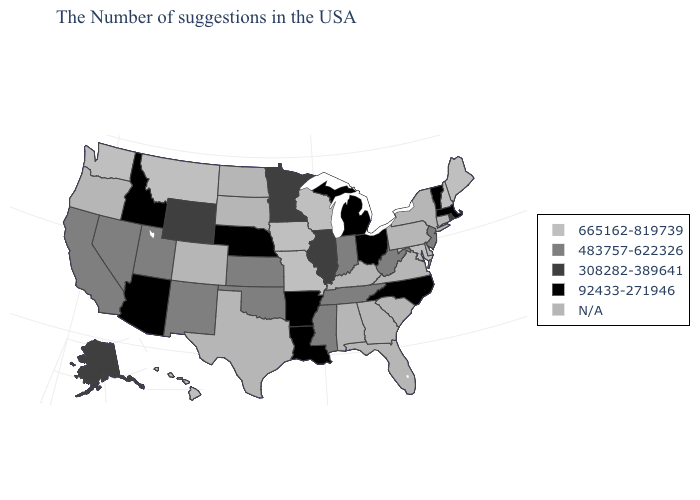Name the states that have a value in the range N/A?
Write a very short answer. Connecticut, New York, Delaware, Pennsylvania, Virginia, South Carolina, Florida, Georgia, Kentucky, Alabama, Texas, South Dakota, North Dakota, Colorado, Oregon. How many symbols are there in the legend?
Answer briefly. 5. Name the states that have a value in the range N/A?
Give a very brief answer. Connecticut, New York, Delaware, Pennsylvania, Virginia, South Carolina, Florida, Georgia, Kentucky, Alabama, Texas, South Dakota, North Dakota, Colorado, Oregon. Name the states that have a value in the range N/A?
Concise answer only. Connecticut, New York, Delaware, Pennsylvania, Virginia, South Carolina, Florida, Georgia, Kentucky, Alabama, Texas, South Dakota, North Dakota, Colorado, Oregon. What is the lowest value in the Northeast?
Be succinct. 92433-271946. Name the states that have a value in the range N/A?
Concise answer only. Connecticut, New York, Delaware, Pennsylvania, Virginia, South Carolina, Florida, Georgia, Kentucky, Alabama, Texas, South Dakota, North Dakota, Colorado, Oregon. Does the first symbol in the legend represent the smallest category?
Write a very short answer. No. Does Ohio have the highest value in the USA?
Write a very short answer. No. Is the legend a continuous bar?
Keep it brief. No. What is the highest value in states that border Massachusetts?
Short answer required. 665162-819739. Does New Jersey have the highest value in the Northeast?
Give a very brief answer. No. Name the states that have a value in the range 92433-271946?
Write a very short answer. Massachusetts, Vermont, North Carolina, Ohio, Michigan, Louisiana, Arkansas, Nebraska, Arizona, Idaho. Name the states that have a value in the range 92433-271946?
Be succinct. Massachusetts, Vermont, North Carolina, Ohio, Michigan, Louisiana, Arkansas, Nebraska, Arizona, Idaho. Name the states that have a value in the range 308282-389641?
Keep it brief. Rhode Island, Illinois, Minnesota, Wyoming, Alaska. 